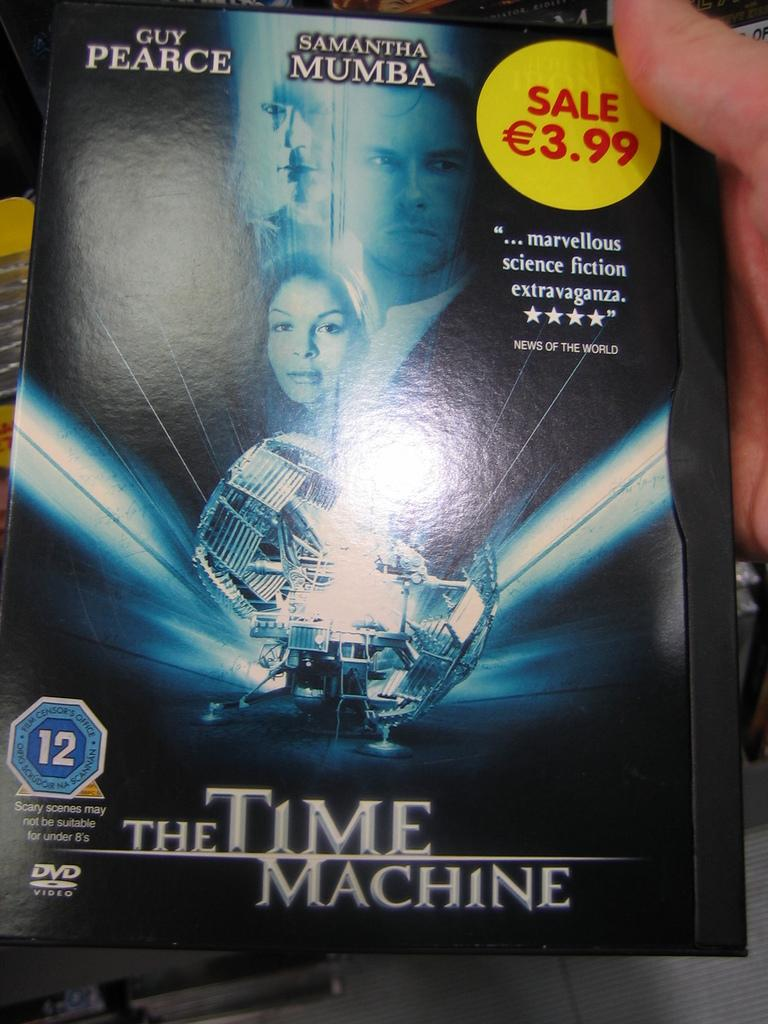<image>
Offer a succinct explanation of the picture presented. The DVD movie The Time Machine and stars Samantha Mumba 